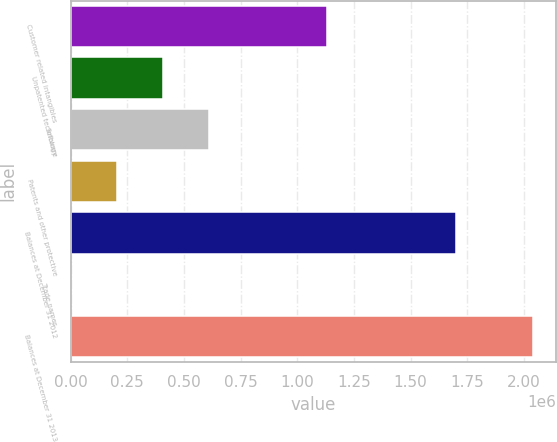Convert chart. <chart><loc_0><loc_0><loc_500><loc_500><bar_chart><fcel>Customer related intangibles<fcel>Unpatented technology<fcel>Software<fcel>Patents and other protective<fcel>Balances at December 31 2012<fcel>Trade names<fcel>Balances at December 31 2013<nl><fcel>1.1298e+06<fcel>408339<fcel>612189<fcel>204490<fcel>1.69887e+06<fcel>640<fcel>2.03914e+06<nl></chart> 